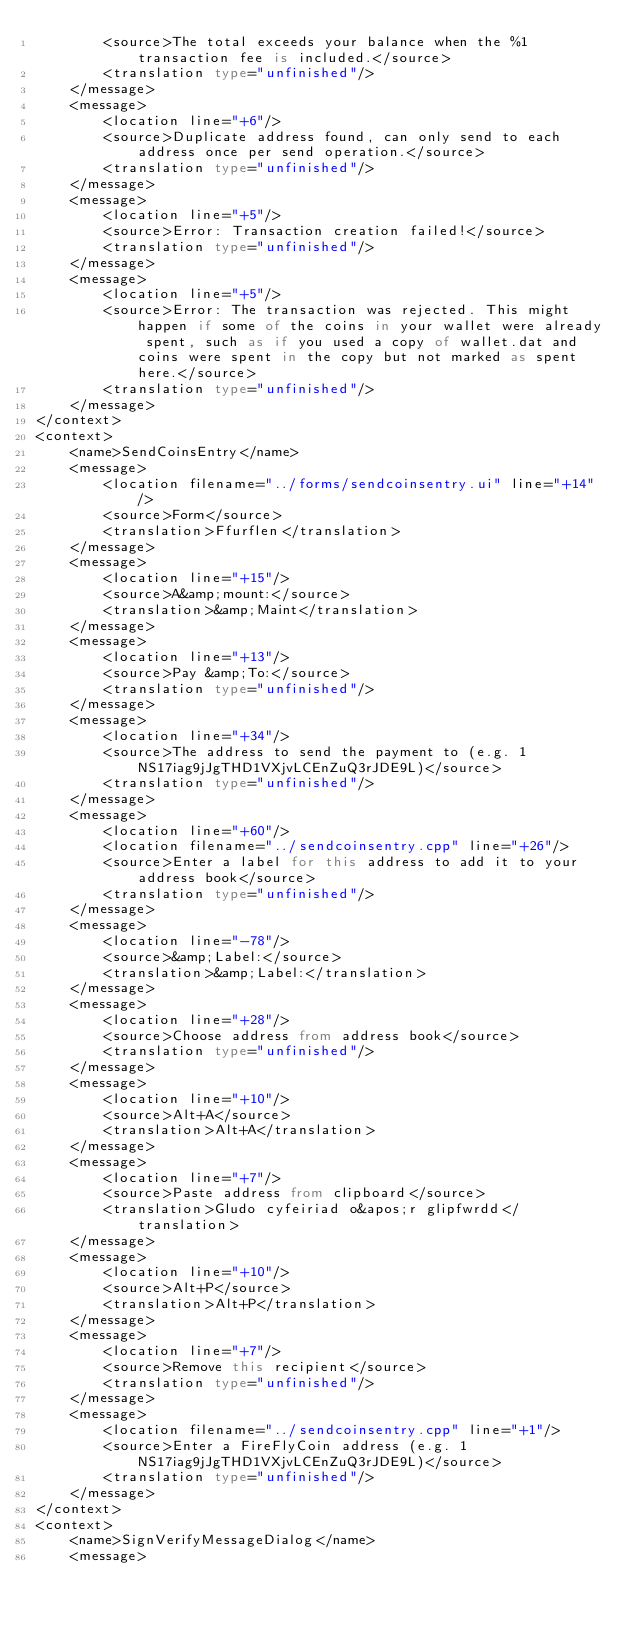Convert code to text. <code><loc_0><loc_0><loc_500><loc_500><_TypeScript_>        <source>The total exceeds your balance when the %1 transaction fee is included.</source>
        <translation type="unfinished"/>
    </message>
    <message>
        <location line="+6"/>
        <source>Duplicate address found, can only send to each address once per send operation.</source>
        <translation type="unfinished"/>
    </message>
    <message>
        <location line="+5"/>
        <source>Error: Transaction creation failed!</source>
        <translation type="unfinished"/>
    </message>
    <message>
        <location line="+5"/>
        <source>Error: The transaction was rejected. This might happen if some of the coins in your wallet were already spent, such as if you used a copy of wallet.dat and coins were spent in the copy but not marked as spent here.</source>
        <translation type="unfinished"/>
    </message>
</context>
<context>
    <name>SendCoinsEntry</name>
    <message>
        <location filename="../forms/sendcoinsentry.ui" line="+14"/>
        <source>Form</source>
        <translation>Ffurflen</translation>
    </message>
    <message>
        <location line="+15"/>
        <source>A&amp;mount:</source>
        <translation>&amp;Maint</translation>
    </message>
    <message>
        <location line="+13"/>
        <source>Pay &amp;To:</source>
        <translation type="unfinished"/>
    </message>
    <message>
        <location line="+34"/>
        <source>The address to send the payment to (e.g. 1NS17iag9jJgTHD1VXjvLCEnZuQ3rJDE9L)</source>
        <translation type="unfinished"/>
    </message>
    <message>
        <location line="+60"/>
        <location filename="../sendcoinsentry.cpp" line="+26"/>
        <source>Enter a label for this address to add it to your address book</source>
        <translation type="unfinished"/>
    </message>
    <message>
        <location line="-78"/>
        <source>&amp;Label:</source>
        <translation>&amp;Label:</translation>
    </message>
    <message>
        <location line="+28"/>
        <source>Choose address from address book</source>
        <translation type="unfinished"/>
    </message>
    <message>
        <location line="+10"/>
        <source>Alt+A</source>
        <translation>Alt+A</translation>
    </message>
    <message>
        <location line="+7"/>
        <source>Paste address from clipboard</source>
        <translation>Gludo cyfeiriad o&apos;r glipfwrdd</translation>
    </message>
    <message>
        <location line="+10"/>
        <source>Alt+P</source>
        <translation>Alt+P</translation>
    </message>
    <message>
        <location line="+7"/>
        <source>Remove this recipient</source>
        <translation type="unfinished"/>
    </message>
    <message>
        <location filename="../sendcoinsentry.cpp" line="+1"/>
        <source>Enter a FireFlyCoin address (e.g. 1NS17iag9jJgTHD1VXjvLCEnZuQ3rJDE9L)</source>
        <translation type="unfinished"/>
    </message>
</context>
<context>
    <name>SignVerifyMessageDialog</name>
    <message></code> 